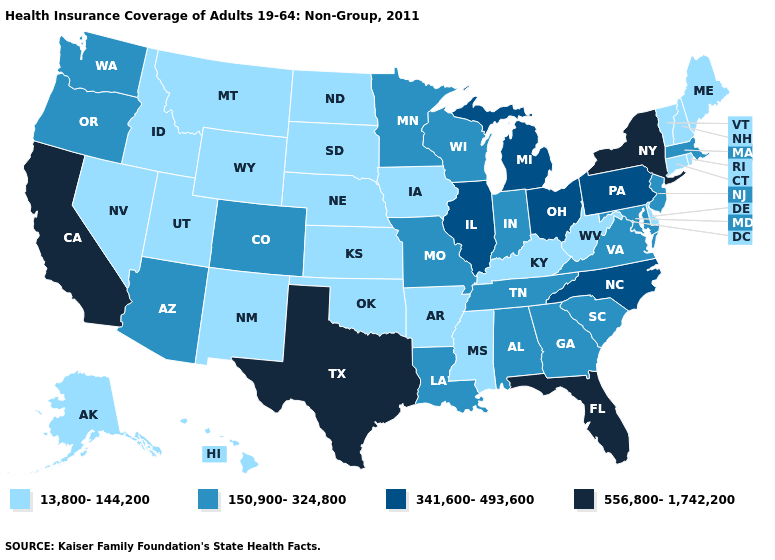What is the value of Vermont?
Quick response, please. 13,800-144,200. Name the states that have a value in the range 13,800-144,200?
Concise answer only. Alaska, Arkansas, Connecticut, Delaware, Hawaii, Idaho, Iowa, Kansas, Kentucky, Maine, Mississippi, Montana, Nebraska, Nevada, New Hampshire, New Mexico, North Dakota, Oklahoma, Rhode Island, South Dakota, Utah, Vermont, West Virginia, Wyoming. What is the value of Georgia?
Concise answer only. 150,900-324,800. What is the lowest value in states that border Alabama?
Write a very short answer. 13,800-144,200. Name the states that have a value in the range 556,800-1,742,200?
Short answer required. California, Florida, New York, Texas. What is the value of Tennessee?
Be succinct. 150,900-324,800. Which states have the lowest value in the MidWest?
Quick response, please. Iowa, Kansas, Nebraska, North Dakota, South Dakota. Which states have the lowest value in the USA?
Short answer required. Alaska, Arkansas, Connecticut, Delaware, Hawaii, Idaho, Iowa, Kansas, Kentucky, Maine, Mississippi, Montana, Nebraska, Nevada, New Hampshire, New Mexico, North Dakota, Oklahoma, Rhode Island, South Dakota, Utah, Vermont, West Virginia, Wyoming. What is the value of Minnesota?
Write a very short answer. 150,900-324,800. What is the highest value in states that border Montana?
Be succinct. 13,800-144,200. Name the states that have a value in the range 150,900-324,800?
Answer briefly. Alabama, Arizona, Colorado, Georgia, Indiana, Louisiana, Maryland, Massachusetts, Minnesota, Missouri, New Jersey, Oregon, South Carolina, Tennessee, Virginia, Washington, Wisconsin. What is the value of Kentucky?
Quick response, please. 13,800-144,200. What is the value of Georgia?
Quick response, please. 150,900-324,800. What is the lowest value in the USA?
Concise answer only. 13,800-144,200. Does New Jersey have the lowest value in the Northeast?
Give a very brief answer. No. 